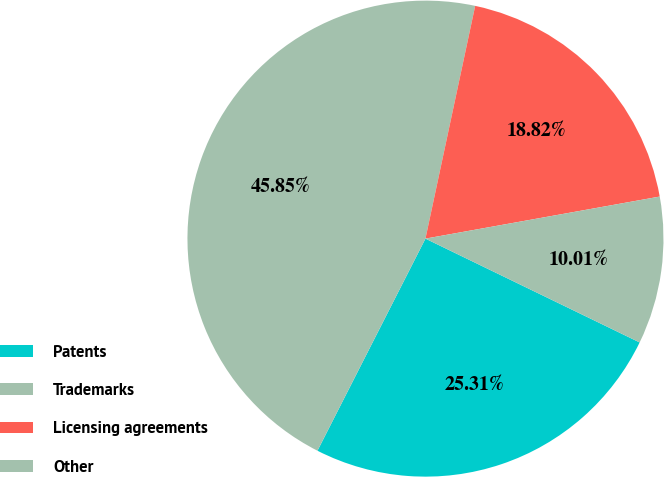<chart> <loc_0><loc_0><loc_500><loc_500><pie_chart><fcel>Patents<fcel>Trademarks<fcel>Licensing agreements<fcel>Other<nl><fcel>25.31%<fcel>45.85%<fcel>18.82%<fcel>10.01%<nl></chart> 